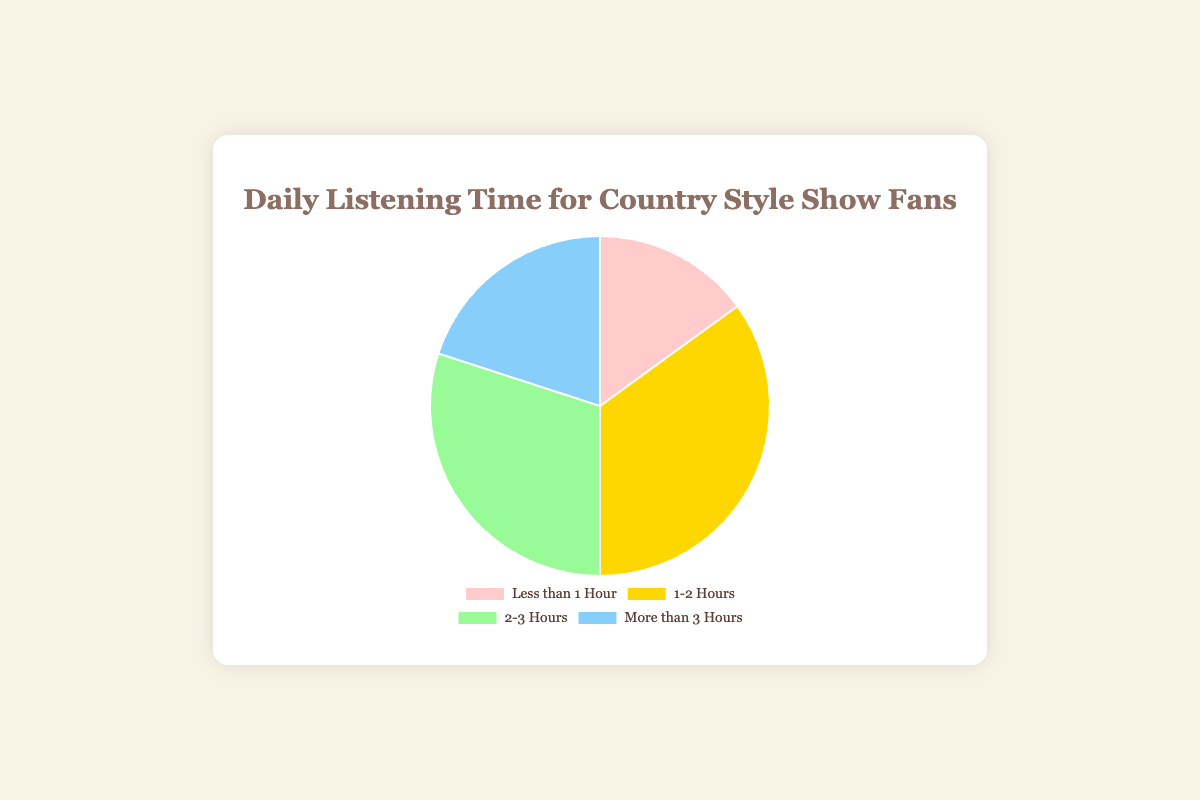What percentage of Country Style Show listeners spend 2-3 hours listening to music daily? Locate the "2-3 Hours" section of the pie chart. The chart indicates that 30% of listeners spend 2-3 hours listening to music daily.
Answer: 30% Which segment is the smallest in terms of the percentage of time spent listening to music? Compare the percentage of each segment: "Less than 1 Hour" (15%), "1-2 Hours" (35%), "2-3 Hours" (30%), and "More than 3 Hours" (20%). The smallest percentage is 15%.
Answer: Less than 1 Hour Which segments combined make up more than half of the total listening time? Sum the percentages of each relevant segment: "1-2 Hours" (35%) and "2-3 Hours" (30%). The combined percentage is 35% + 30% = 65%, which is more than half.
Answer: 1-2 Hours and 2-3 Hours How much higher is the percentage of listeners who spend 1-2 hours listening than those who listen for less than 1 hour? Subtract the percentage of "Less than 1 Hour" (15%) from "1-2 Hours" (35%): 35% - 15% = 20%.
Answer: 20% What is the combined percentage of listeners who spend either less than 1 hour or more than 3 hours listening to music daily? Add the percentage of "Less than 1 Hour" (15%) and "More than 3 Hours" (20%): 15% + 20% = 35%.
Answer: 35% Which color represents listeners who spend more than 3 hours listening to music? Locate the "More than 3 Hours" segment on the pie chart, which is represented by the blue color.
Answer: Blue Is there a larger percentage of listeners who spend 2-3 hours listening to music compared to those who spend more than 3 hours? Compare the percentages of "2-3 Hours" (30%) and "More than 3 Hours" (20%). The percentage for "2-3 Hours" is larger.
Answer: Yes What proportion of listeners spend 1-2 hours or more than 3 hours listening to music? Add the percentage of "1-2 Hours" (35%) and "More than 3 Hours" (20%): 35% + 20% = 55%.
Answer: 55% How does the percentage of listeners who spend less than 1 hour listening compare to those who listen for 2-3 hours? Compare the percentages directly: "Less than 1 Hour" is 15%, and "2-3 Hours" is 30%. The "2-3 Hours" category is double the "Less than 1 Hour" category.
Answer: 2-3 Hours is double How many times larger is the percentage of listeners who spend 1-2 hours listening compared to those who spend less than 1 hour? Divide the percentage of "1-2 Hours" (35%) by "Less than 1 Hour" (15%): 35 / 15 ≈ 2.33 times.
Answer: 2.33 times 